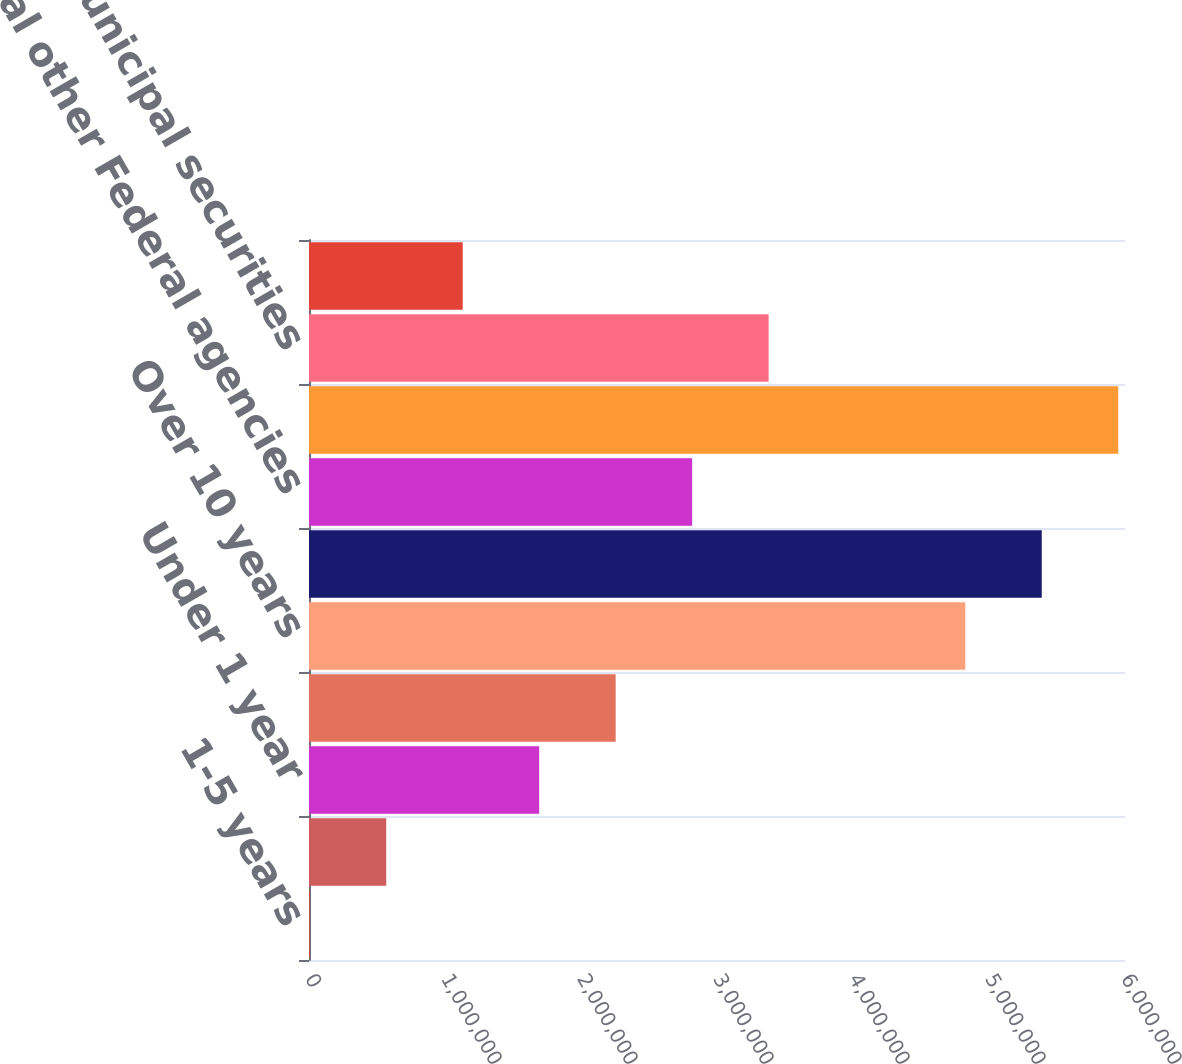Convert chart. <chart><loc_0><loc_0><loc_500><loc_500><bar_chart><fcel>1-5 years<fcel>Total US Treasury<fcel>Under 1 year<fcel>6-10 years<fcel>Over 10 years<fcel>Total Federal agencies<fcel>Total other Federal agencies<fcel>Total US Treasury Federal<fcel>Total municipal securities<fcel>Total private label CMO<nl><fcel>5435<fcel>567796<fcel>1.69252e+06<fcel>2.25488e+06<fcel>4.82552e+06<fcel>5.38789e+06<fcel>2.81724e+06<fcel>5.95025e+06<fcel>3.3796e+06<fcel>1.13016e+06<nl></chart> 